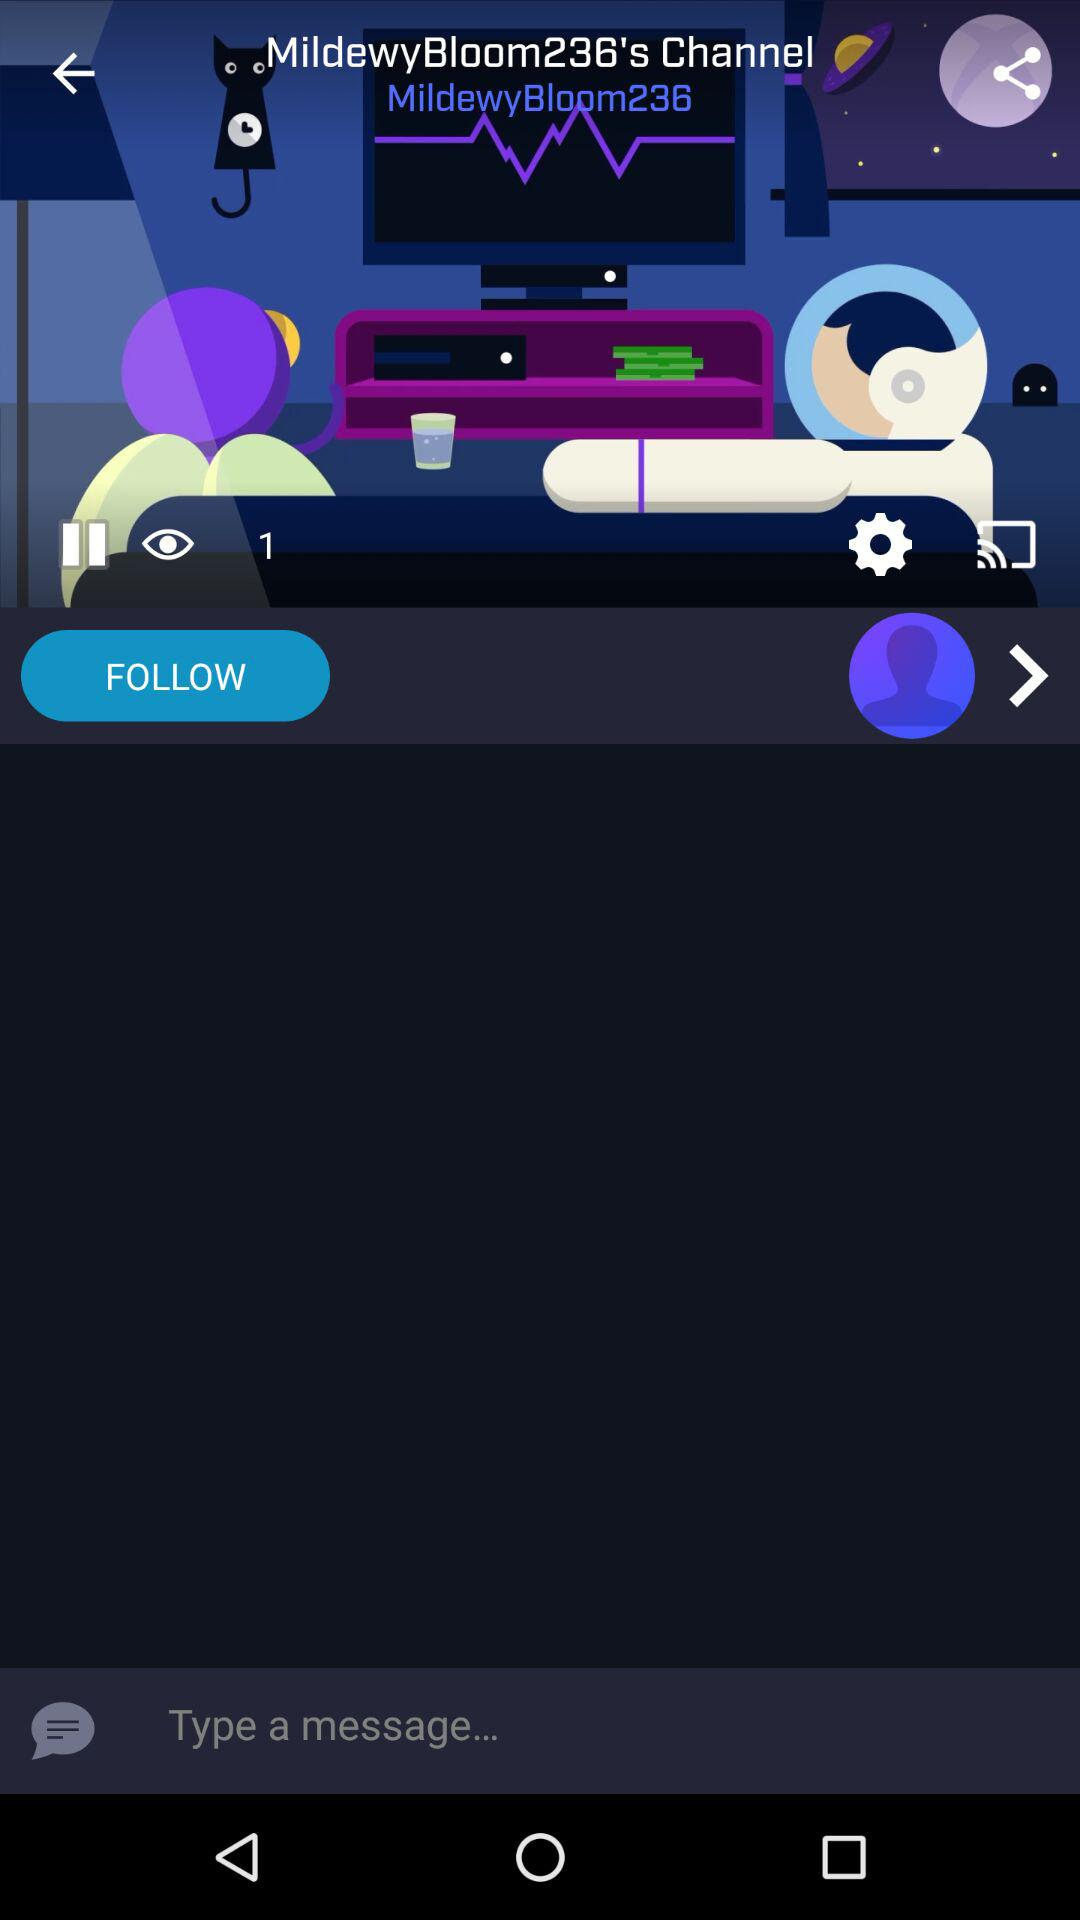How many viewers are there? There is 1 viewer. 